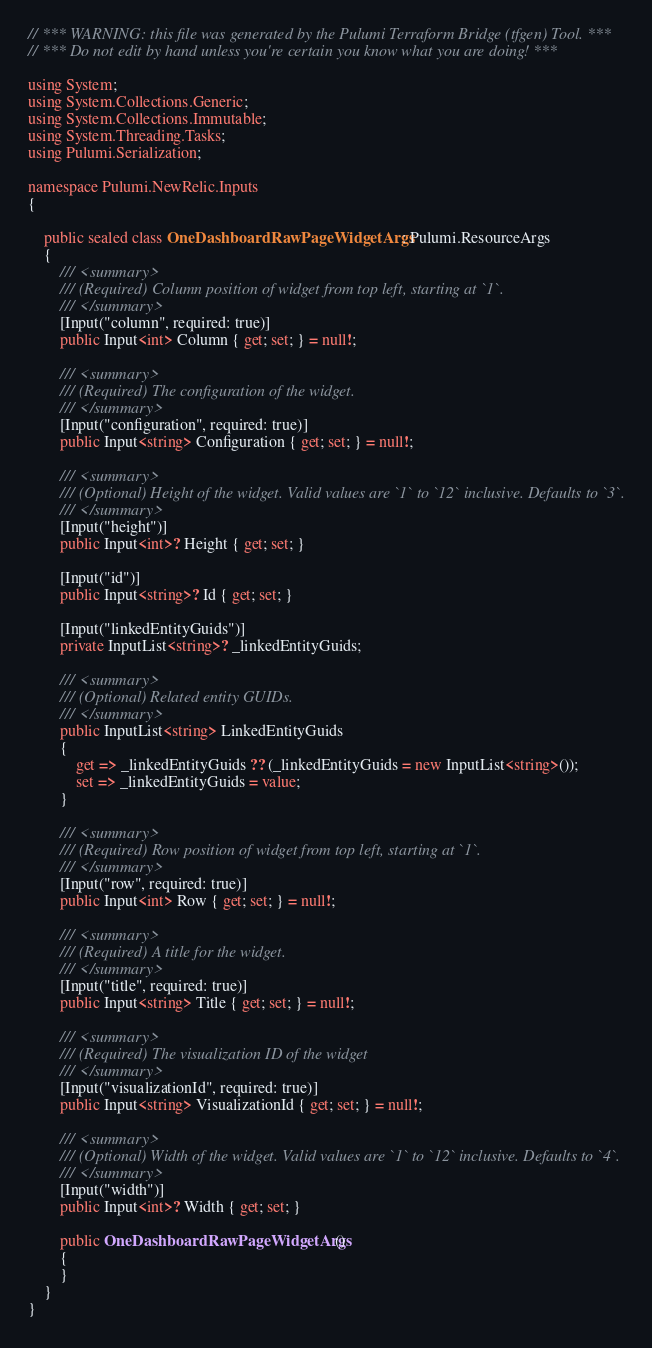Convert code to text. <code><loc_0><loc_0><loc_500><loc_500><_C#_>// *** WARNING: this file was generated by the Pulumi Terraform Bridge (tfgen) Tool. ***
// *** Do not edit by hand unless you're certain you know what you are doing! ***

using System;
using System.Collections.Generic;
using System.Collections.Immutable;
using System.Threading.Tasks;
using Pulumi.Serialization;

namespace Pulumi.NewRelic.Inputs
{

    public sealed class OneDashboardRawPageWidgetArgs : Pulumi.ResourceArgs
    {
        /// <summary>
        /// (Required) Column position of widget from top left, starting at `1`.
        /// </summary>
        [Input("column", required: true)]
        public Input<int> Column { get; set; } = null!;

        /// <summary>
        /// (Required) The configuration of the widget.
        /// </summary>
        [Input("configuration", required: true)]
        public Input<string> Configuration { get; set; } = null!;

        /// <summary>
        /// (Optional) Height of the widget. Valid values are `1` to `12` inclusive. Defaults to `3`.
        /// </summary>
        [Input("height")]
        public Input<int>? Height { get; set; }

        [Input("id")]
        public Input<string>? Id { get; set; }

        [Input("linkedEntityGuids")]
        private InputList<string>? _linkedEntityGuids;

        /// <summary>
        /// (Optional) Related entity GUIDs.
        /// </summary>
        public InputList<string> LinkedEntityGuids
        {
            get => _linkedEntityGuids ?? (_linkedEntityGuids = new InputList<string>());
            set => _linkedEntityGuids = value;
        }

        /// <summary>
        /// (Required) Row position of widget from top left, starting at `1`.
        /// </summary>
        [Input("row", required: true)]
        public Input<int> Row { get; set; } = null!;

        /// <summary>
        /// (Required) A title for the widget.
        /// </summary>
        [Input("title", required: true)]
        public Input<string> Title { get; set; } = null!;

        /// <summary>
        /// (Required) The visualization ID of the widget
        /// </summary>
        [Input("visualizationId", required: true)]
        public Input<string> VisualizationId { get; set; } = null!;

        /// <summary>
        /// (Optional) Width of the widget. Valid values are `1` to `12` inclusive. Defaults to `4`.
        /// </summary>
        [Input("width")]
        public Input<int>? Width { get; set; }

        public OneDashboardRawPageWidgetArgs()
        {
        }
    }
}
</code> 